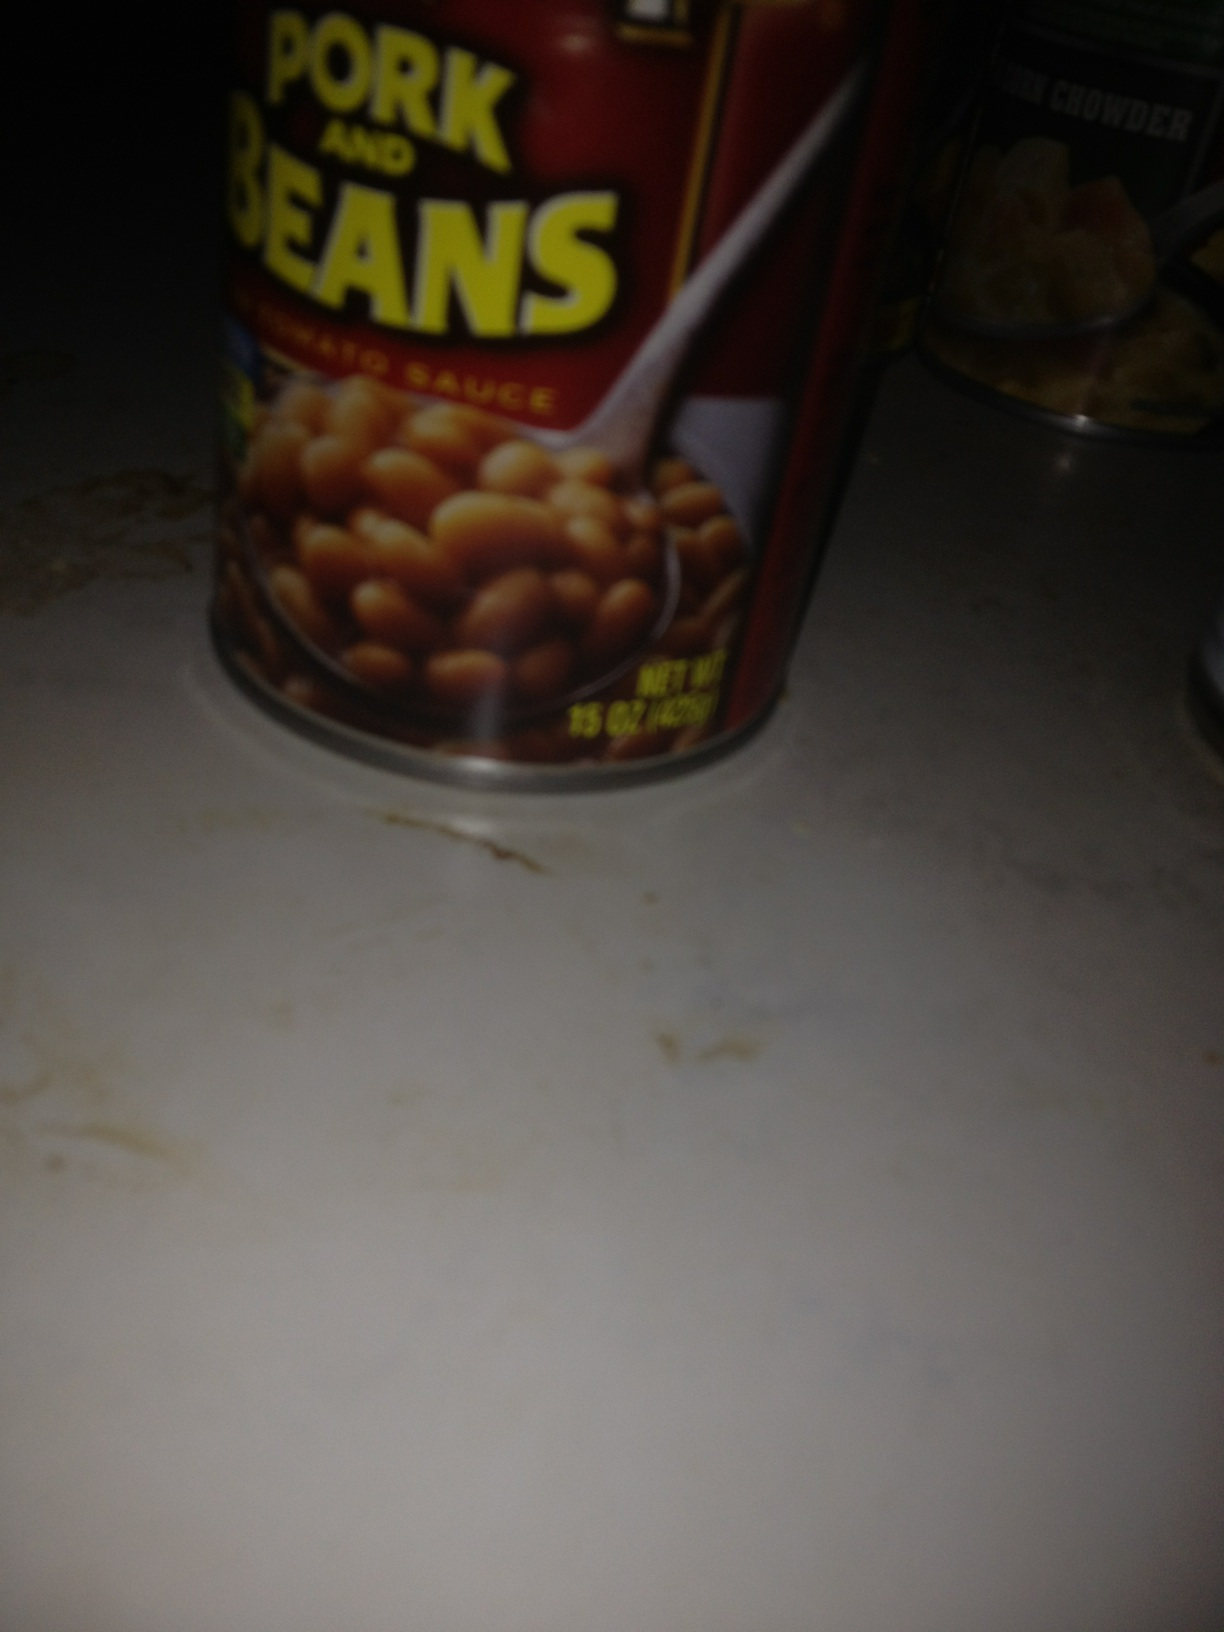What can you tell me about the packaging design of the can in the foreground? The can in the foreground has a vibrant, eye-catching design that prominently features the product name, 'Pork and Beans'. The label uses bold, yellow lettering on a red background, which contrasts well and grabs attention. There is also an image of a spoonful of beans, displaying the product in an appetizing way. The text indicates that the beans are in tomato sauce and the net weight is 15 ounces (425 grams). Overall, the packaging is designed to be appealing and informative, quickly conveying the contents and the flavor. Why do you think the manufacturer chose these specific design elements? Manufacturers often choose design elements based on several key factors: visibility, readability, and attractiveness. The bold, yellow text on a red background is highly visible and readable, especially from a distance, helping the product to stand out on store shelves. The image of the beans on a spoon serves to make the product look appetizing and gives potential buyers a visual cue of what they are purchasing. Red is also a color commonly associated with appetite and excitement, which can attract consumers looking for a tasty meal. Additionally, the concise description and clear display of product weight ensure that the buyer has the necessary information at a glance. 